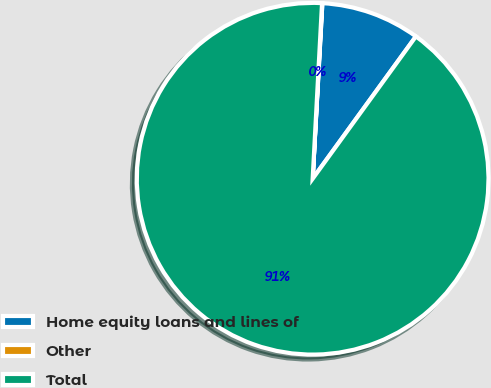Convert chart. <chart><loc_0><loc_0><loc_500><loc_500><pie_chart><fcel>Home equity loans and lines of<fcel>Other<fcel>Total<nl><fcel>9.11%<fcel>0.03%<fcel>90.86%<nl></chart> 